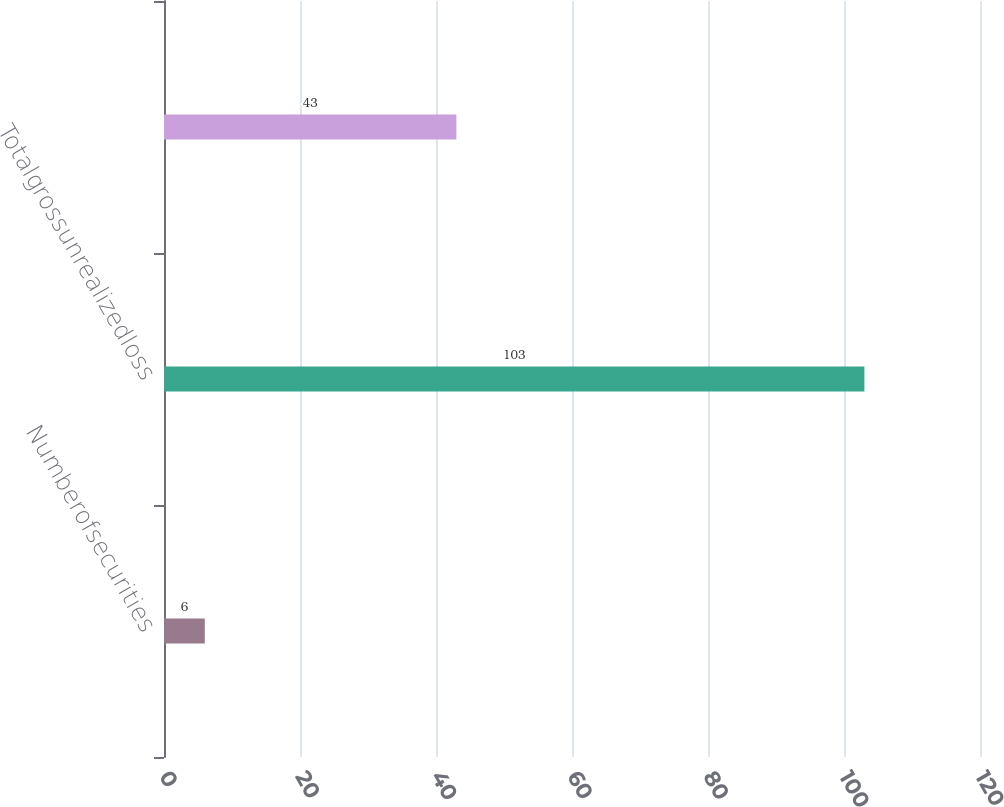<chart> <loc_0><loc_0><loc_500><loc_500><bar_chart><fcel>Numberofsecurities<fcel>Totalgrossunrealizedloss<fcel>Unnamed: 2<nl><fcel>6<fcel>103<fcel>43<nl></chart> 